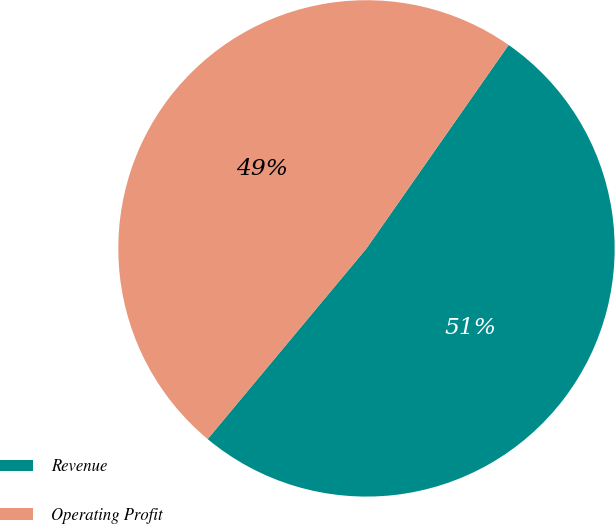Convert chart to OTSL. <chart><loc_0><loc_0><loc_500><loc_500><pie_chart><fcel>Revenue<fcel>Operating Profit<nl><fcel>51.35%<fcel>48.65%<nl></chart> 